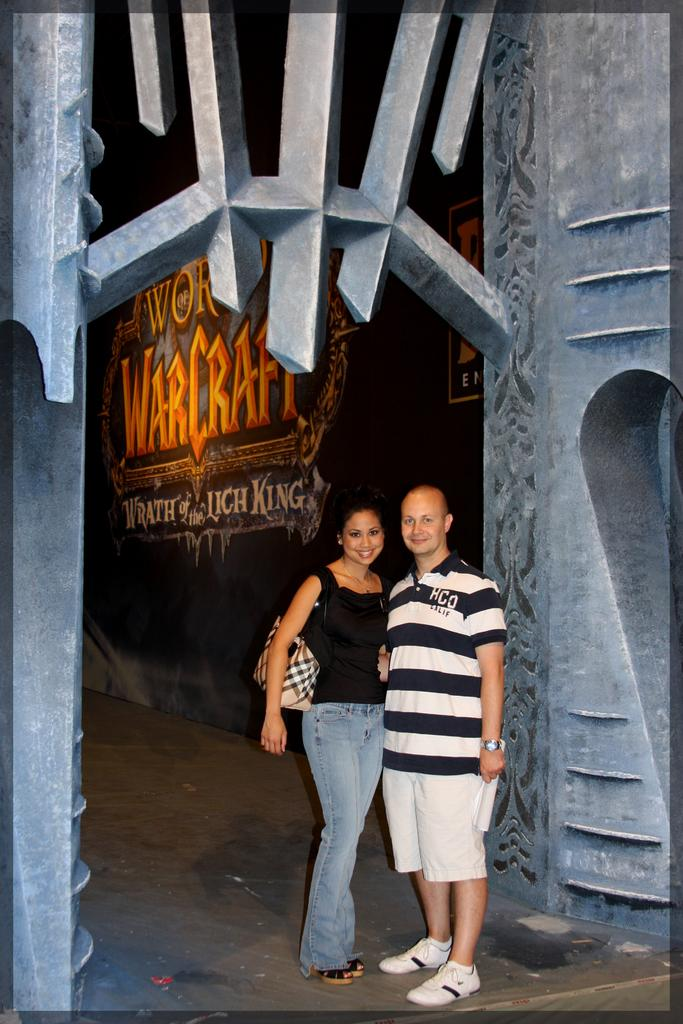How many people are in the image? There are two people in the image, a man and a woman. Where are the man and woman located in the image? The man and woman are in the center of the image. What can be seen in the background of the image? There is a poster in the background of the image. What type of liquid is being poured from the cloud in the image? There is no cloud or liquid present in the image; it features a man, a woman, and a poster in the background. 